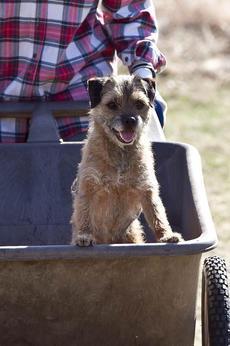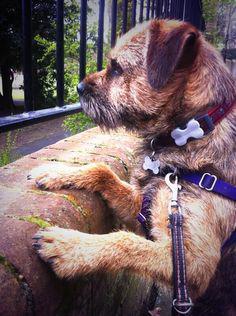The first image is the image on the left, the second image is the image on the right. Analyze the images presented: Is the assertion "An image includes a standing dog with its body turned leftward and its tail extended outward." valid? Answer yes or no. No. The first image is the image on the left, the second image is the image on the right. Considering the images on both sides, is "The dog in the image on the left is on a green grassy surface." valid? Answer yes or no. No. 